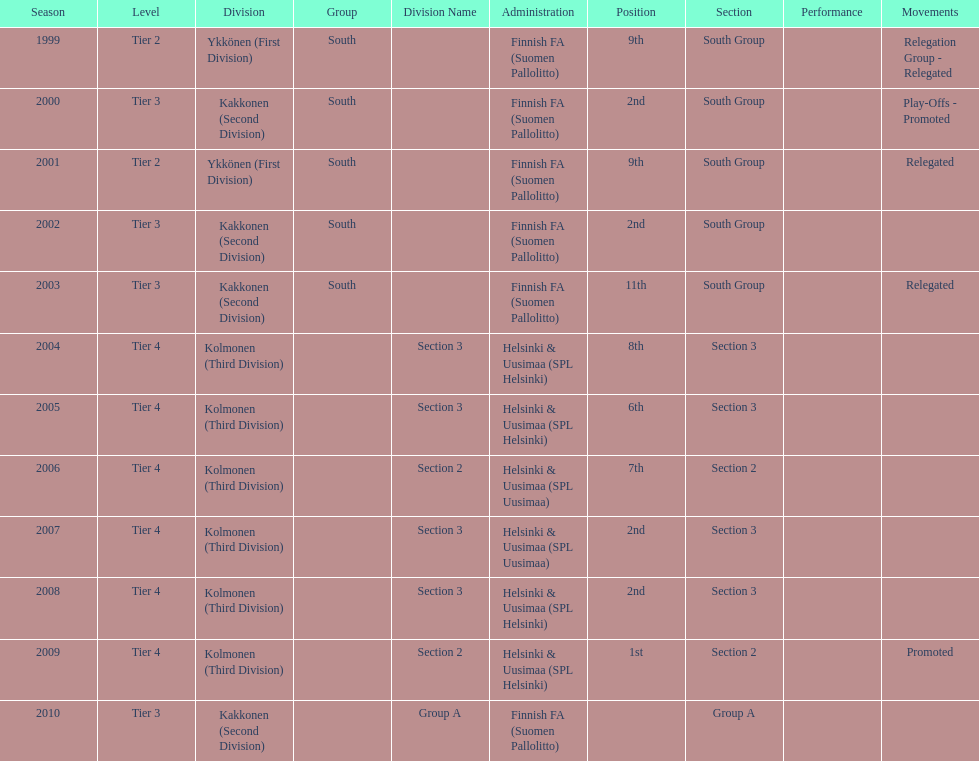Which administration has the least amount of division? Helsinki & Uusimaa (SPL Helsinki). 